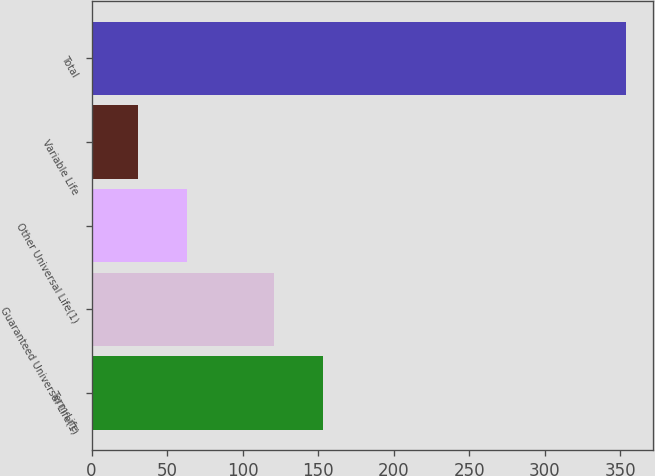Convert chart. <chart><loc_0><loc_0><loc_500><loc_500><bar_chart><fcel>Term Life<fcel>Guaranteed Universal Life(1)<fcel>Other Universal Life(1)<fcel>Variable Life<fcel>Total<nl><fcel>153.3<fcel>121<fcel>63.3<fcel>31<fcel>354<nl></chart> 